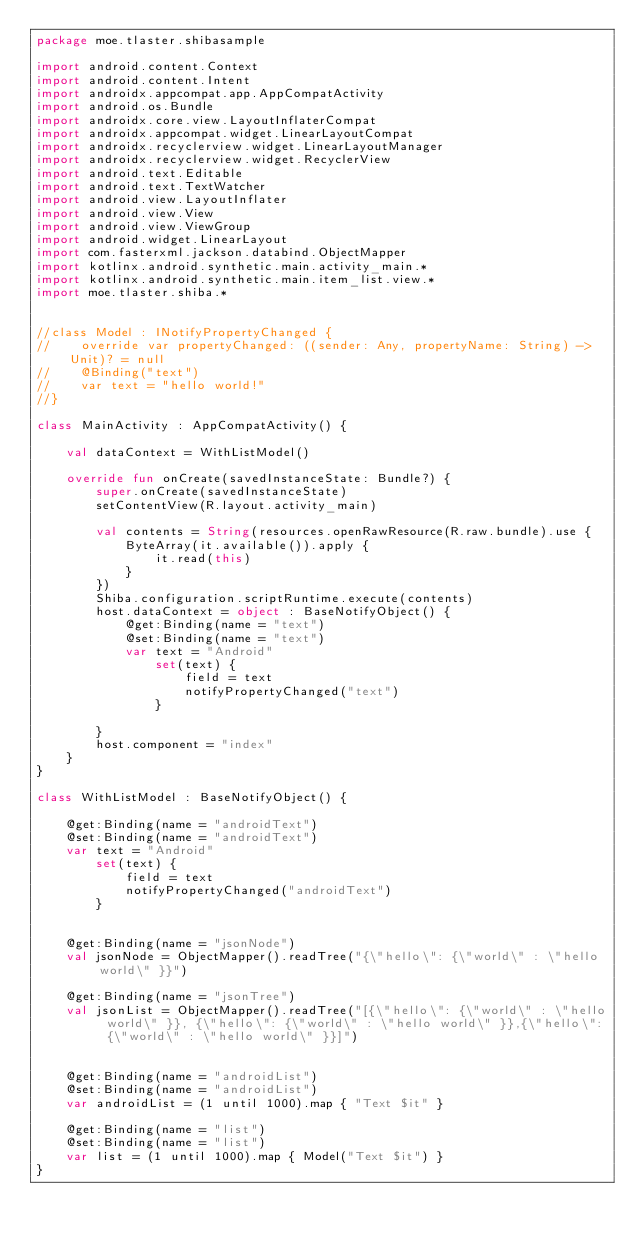<code> <loc_0><loc_0><loc_500><loc_500><_Kotlin_>package moe.tlaster.shibasample

import android.content.Context
import android.content.Intent
import androidx.appcompat.app.AppCompatActivity
import android.os.Bundle
import androidx.core.view.LayoutInflaterCompat
import androidx.appcompat.widget.LinearLayoutCompat
import androidx.recyclerview.widget.LinearLayoutManager
import androidx.recyclerview.widget.RecyclerView
import android.text.Editable
import android.text.TextWatcher
import android.view.LayoutInflater
import android.view.View
import android.view.ViewGroup
import android.widget.LinearLayout
import com.fasterxml.jackson.databind.ObjectMapper
import kotlinx.android.synthetic.main.activity_main.*
import kotlinx.android.synthetic.main.item_list.view.*
import moe.tlaster.shiba.*


//class Model : INotifyPropertyChanged {
//    override var propertyChanged: ((sender: Any, propertyName: String) -> Unit)? = null
//    @Binding("text")
//    var text = "hello world!"
//}

class MainActivity : AppCompatActivity() {

    val dataContext = WithListModel()

    override fun onCreate(savedInstanceState: Bundle?) {
        super.onCreate(savedInstanceState)
        setContentView(R.layout.activity_main)

        val contents = String(resources.openRawResource(R.raw.bundle).use {
            ByteArray(it.available()).apply {
                it.read(this)
            }
        })
        Shiba.configuration.scriptRuntime.execute(contents)
        host.dataContext = object : BaseNotifyObject() {
            @get:Binding(name = "text")
            @set:Binding(name = "text")
            var text = "Android"
                set(text) {
                    field = text
                    notifyPropertyChanged("text")
                }

        }
        host.component = "index"
    }
}

class WithListModel : BaseNotifyObject() {

    @get:Binding(name = "androidText")
    @set:Binding(name = "androidText")
    var text = "Android"
        set(text) {
            field = text
            notifyPropertyChanged("androidText")
        }


    @get:Binding(name = "jsonNode")
    val jsonNode = ObjectMapper().readTree("{\"hello\": {\"world\" : \"hello world\" }}")

    @get:Binding(name = "jsonTree")
    val jsonList = ObjectMapper().readTree("[{\"hello\": {\"world\" : \"hello world\" }}, {\"hello\": {\"world\" : \"hello world\" }},{\"hello\": {\"world\" : \"hello world\" }}]")


    @get:Binding(name = "androidList")
    @set:Binding(name = "androidList")
    var androidList = (1 until 1000).map { "Text $it" }

    @get:Binding(name = "list")
    @set:Binding(name = "list")
    var list = (1 until 1000).map { Model("Text $it") }
}

</code> 